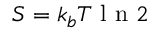<formula> <loc_0><loc_0><loc_500><loc_500>S = k _ { b } T l n 2</formula> 